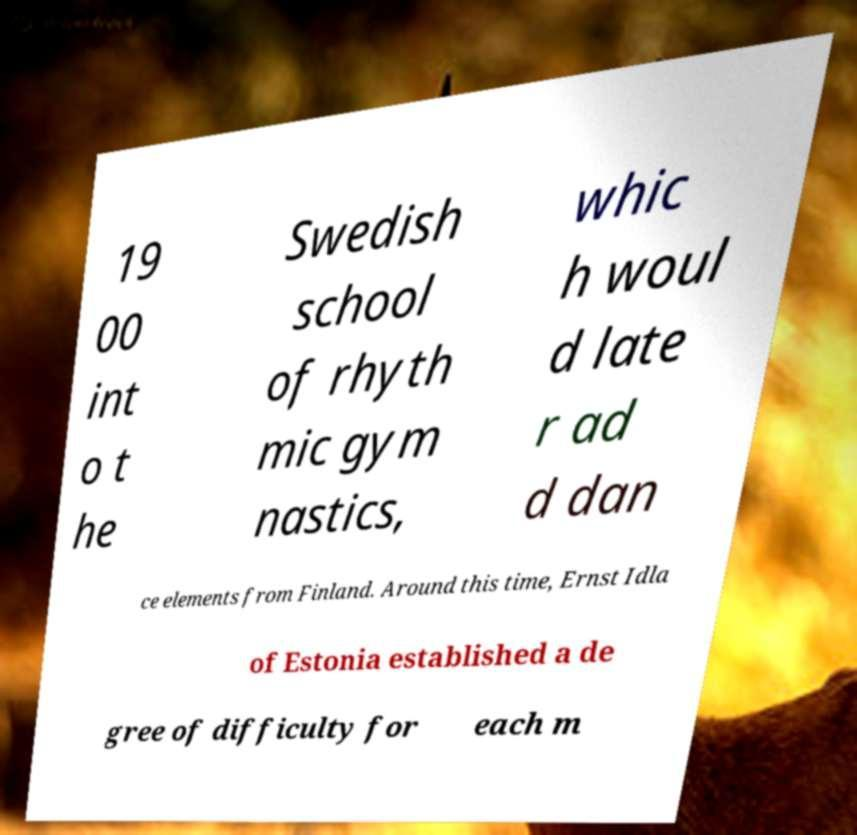What messages or text are displayed in this image? I need them in a readable, typed format. 19 00 int o t he Swedish school of rhyth mic gym nastics, whic h woul d late r ad d dan ce elements from Finland. Around this time, Ernst Idla of Estonia established a de gree of difficulty for each m 